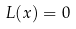Convert formula to latex. <formula><loc_0><loc_0><loc_500><loc_500>L ( x ) = 0</formula> 